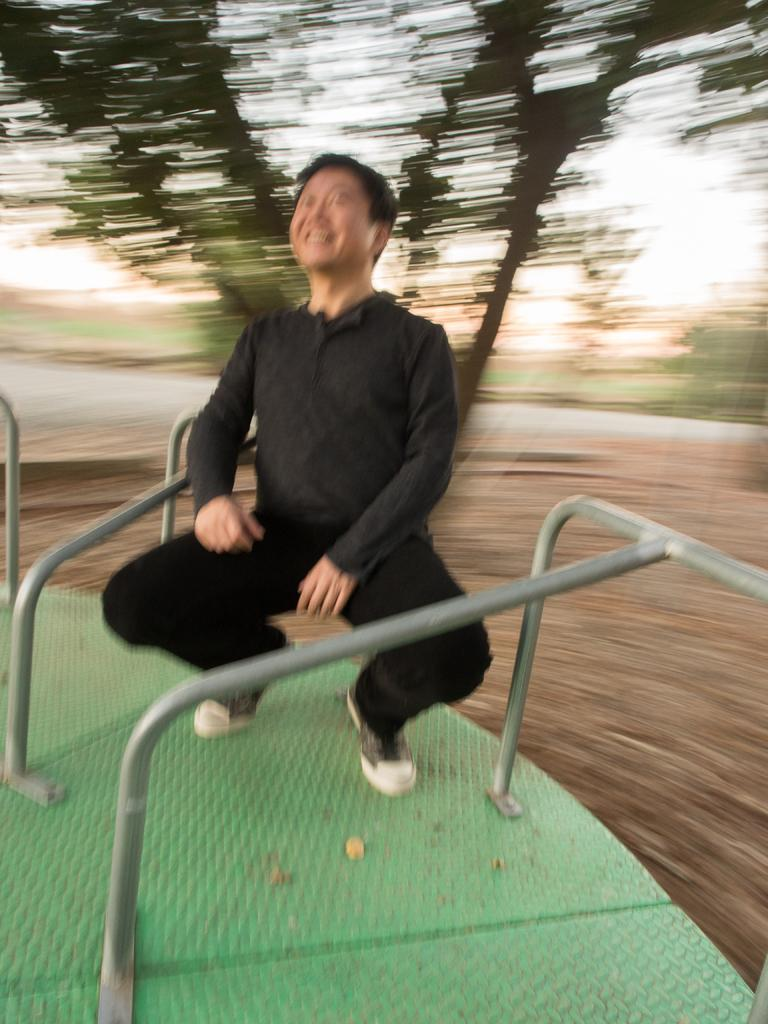What is the main subject of the image? There is a person in the image. How is the person positioned in the image? The person is sitting in a squat position. What type of object can be seen in the image? There is a metal object in the image. Can you describe the background of the image? The background of the image is blurred. What type of smell can be detected in the image? There is no information about smells in the image, so it cannot be determined from the image. 